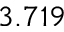Convert formula to latex. <formula><loc_0><loc_0><loc_500><loc_500>3 . 7 1 9</formula> 